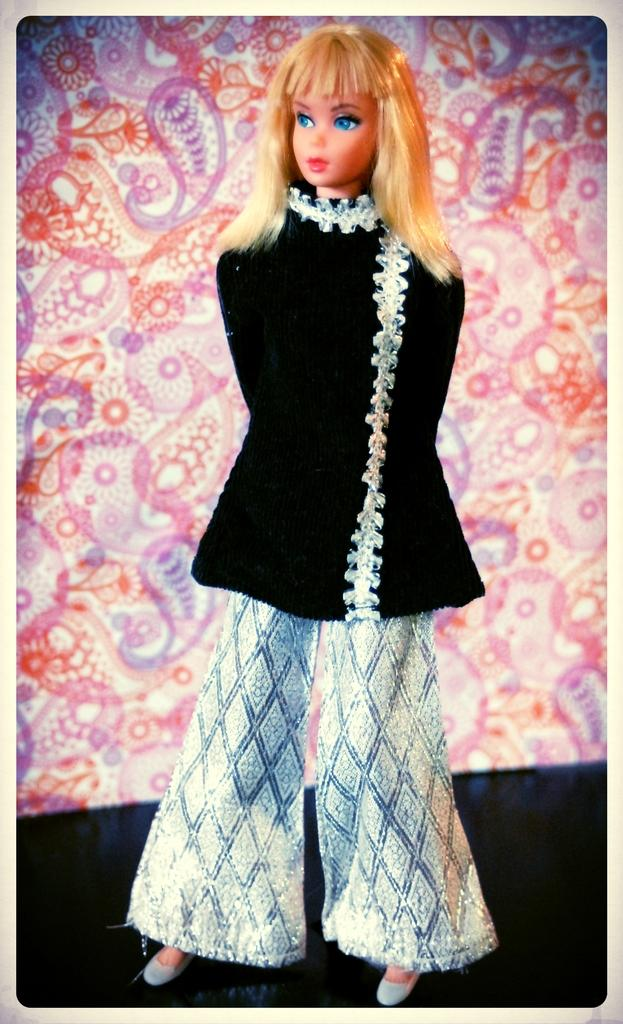What is the main subject in the image? There is a doll in the image. Where is the doll located in relation to the image? The doll is near the borders of the image. What type of background is present in the image? There is a color background in the image. What is visible at the bottom of the image? There is a floor visible at the bottom of the image. What type of steel desk can be seen in the image? There is no desk, steel or otherwise, present in the image. What kind of juice is being served in the image? There is no juice or any indication of a beverage in the image. 